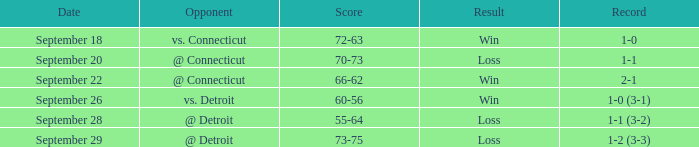What is the count with a history of 1-0? 72-63. 